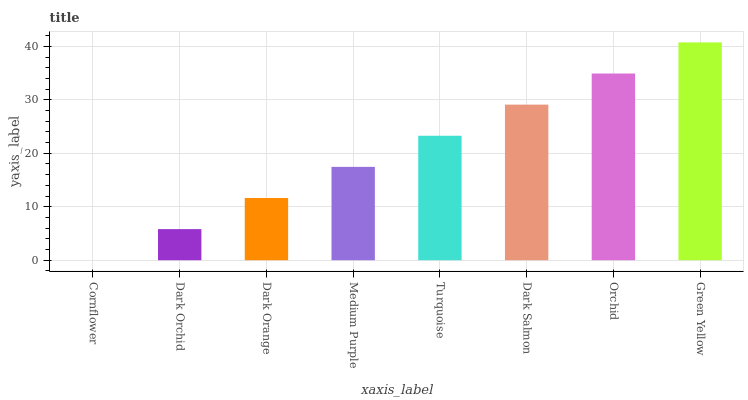Is Cornflower the minimum?
Answer yes or no. Yes. Is Green Yellow the maximum?
Answer yes or no. Yes. Is Dark Orchid the minimum?
Answer yes or no. No. Is Dark Orchid the maximum?
Answer yes or no. No. Is Dark Orchid greater than Cornflower?
Answer yes or no. Yes. Is Cornflower less than Dark Orchid?
Answer yes or no. Yes. Is Cornflower greater than Dark Orchid?
Answer yes or no. No. Is Dark Orchid less than Cornflower?
Answer yes or no. No. Is Turquoise the high median?
Answer yes or no. Yes. Is Medium Purple the low median?
Answer yes or no. Yes. Is Dark Orange the high median?
Answer yes or no. No. Is Orchid the low median?
Answer yes or no. No. 